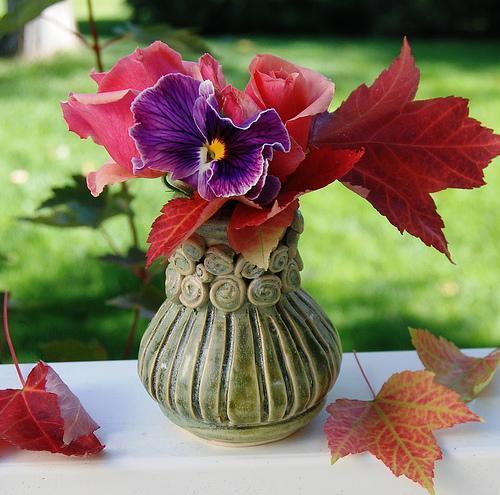How many violets are in the picture?
Give a very brief answer. 1. How many roses are in the picture?
Give a very brief answer. 2. 